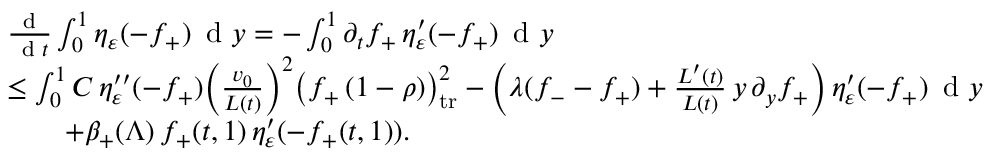Convert formula to latex. <formula><loc_0><loc_0><loc_500><loc_500>\begin{array} { r l } & { \frac { d } { \, d t } \int _ { 0 } ^ { 1 } \eta _ { \varepsilon } ( - f _ { + } ) \, d y = - \int _ { 0 } ^ { 1 } \partial _ { t } f _ { + } \, \eta _ { \varepsilon } ^ { \prime } ( - f _ { + } ) \, d y } \\ & { \leq \int _ { 0 } ^ { 1 } C \, \eta _ { \varepsilon } ^ { \prime \prime } ( - f _ { + } ) \left ( \frac { v _ { 0 } } { L ( t ) } \right ) ^ { 2 } \left ( f _ { + } \, ( 1 - \rho ) \right ) _ { t r } ^ { 2 } - \left ( \lambda ( f _ { - } - f _ { + } ) + \frac { L ^ { \prime } ( t ) } { L ( t ) } \, y \, \partial _ { y } f _ { + } \right ) \eta _ { \varepsilon } ^ { \prime } ( - f _ { + } ) \, d y } \\ & { \quad + \beta _ { + } ( \Lambda ) \, f _ { + } ( t , 1 ) \, \eta _ { \varepsilon } ^ { \prime } ( - f _ { + } ( t , 1 ) ) . } \end{array}</formula> 